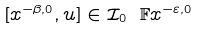Convert formula to latex. <formula><loc_0><loc_0><loc_500><loc_500>[ x ^ { - \beta , 0 } , u ] \in \mathcal { I } _ { 0 } \ \mathbb { F } x ^ { - \varepsilon , 0 }</formula> 